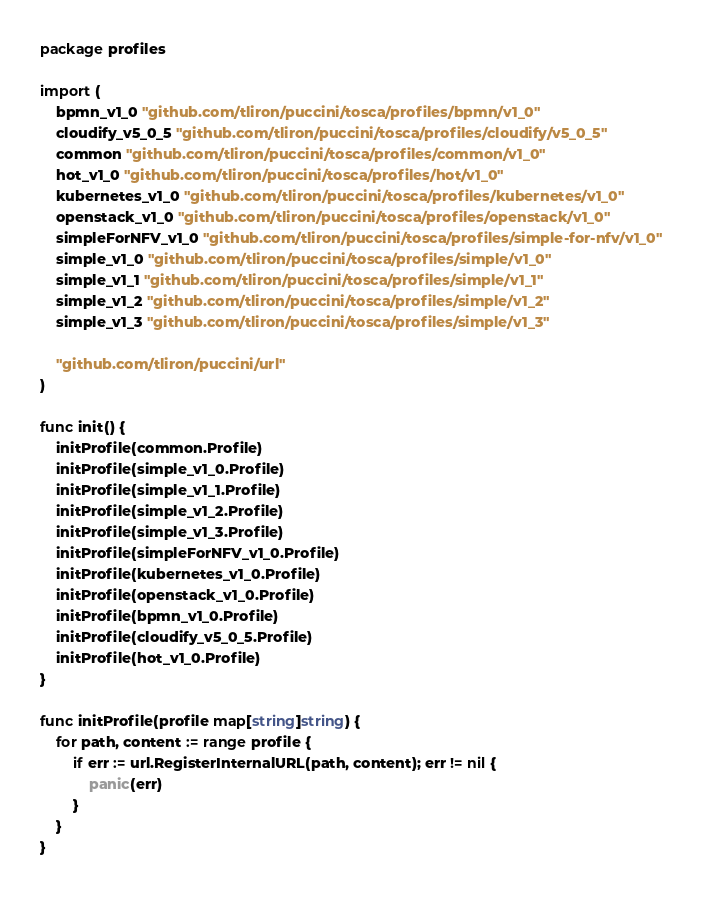<code> <loc_0><loc_0><loc_500><loc_500><_Go_>package profiles

import (
	bpmn_v1_0 "github.com/tliron/puccini/tosca/profiles/bpmn/v1_0"
	cloudify_v5_0_5 "github.com/tliron/puccini/tosca/profiles/cloudify/v5_0_5"
	common "github.com/tliron/puccini/tosca/profiles/common/v1_0"
	hot_v1_0 "github.com/tliron/puccini/tosca/profiles/hot/v1_0"
	kubernetes_v1_0 "github.com/tliron/puccini/tosca/profiles/kubernetes/v1_0"
	openstack_v1_0 "github.com/tliron/puccini/tosca/profiles/openstack/v1_0"
	simpleForNFV_v1_0 "github.com/tliron/puccini/tosca/profiles/simple-for-nfv/v1_0"
	simple_v1_0 "github.com/tliron/puccini/tosca/profiles/simple/v1_0"
	simple_v1_1 "github.com/tliron/puccini/tosca/profiles/simple/v1_1"
	simple_v1_2 "github.com/tliron/puccini/tosca/profiles/simple/v1_2"
	simple_v1_3 "github.com/tliron/puccini/tosca/profiles/simple/v1_3"

	"github.com/tliron/puccini/url"
)

func init() {
	initProfile(common.Profile)
	initProfile(simple_v1_0.Profile)
	initProfile(simple_v1_1.Profile)
	initProfile(simple_v1_2.Profile)
	initProfile(simple_v1_3.Profile)
	initProfile(simpleForNFV_v1_0.Profile)
	initProfile(kubernetes_v1_0.Profile)
	initProfile(openstack_v1_0.Profile)
	initProfile(bpmn_v1_0.Profile)
	initProfile(cloudify_v5_0_5.Profile)
	initProfile(hot_v1_0.Profile)
}

func initProfile(profile map[string]string) {
	for path, content := range profile {
		if err := url.RegisterInternalURL(path, content); err != nil {
			panic(err)
		}
	}
}
</code> 